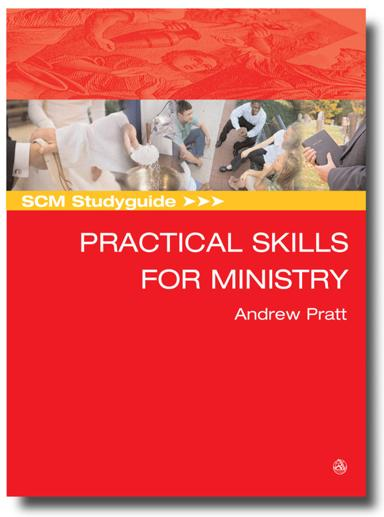What is the title of the book or brochure mentioned in the image? The book depicted in the image is titled "SCM Studyguide: Practical Skills for Ministry", written by Andrew Pratt. It appears to be part of the SCM Studyguide series known for offering accessible educational resources. 